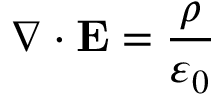Convert formula to latex. <formula><loc_0><loc_0><loc_500><loc_500>\nabla \cdot E = { \frac { \rho } { \varepsilon _ { 0 } } }</formula> 